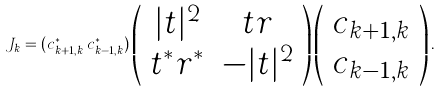<formula> <loc_0><loc_0><loc_500><loc_500>J _ { k } = ( c ^ { \ast } _ { k + 1 , k } \, c ^ { \ast } _ { k - 1 , k } ) \left ( \begin{array} { c c } | t | ^ { 2 } & t r \\ t ^ { \ast } r ^ { \ast } & - | t | ^ { 2 } \end{array} \right ) \left ( \begin{array} { c } c _ { k + 1 , k } \\ c _ { k - 1 , k } \end{array} \right ) .</formula> 